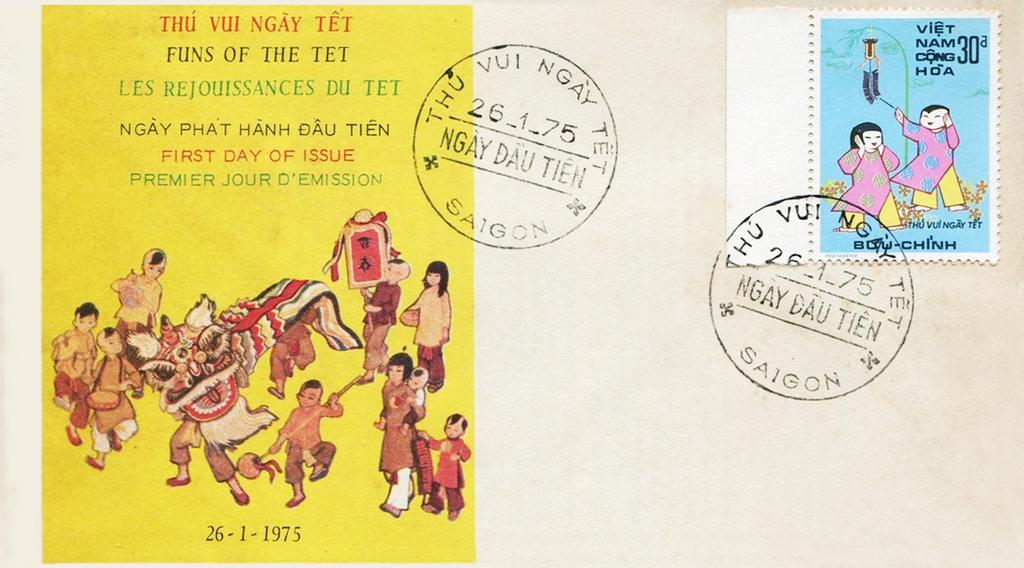What is present on the paper in the image? The paper has stamps, text, and pictures on it. What type of markings can be seen on the paper? The paper has stamps on it. What else is visible on the paper besides the stamps? There is text and pictures on the paper. What type of baseball equipment can be seen in the image? There is no baseball equipment present in the image. Where is the pocket located on the paper? There is no pocket present on the paper. 